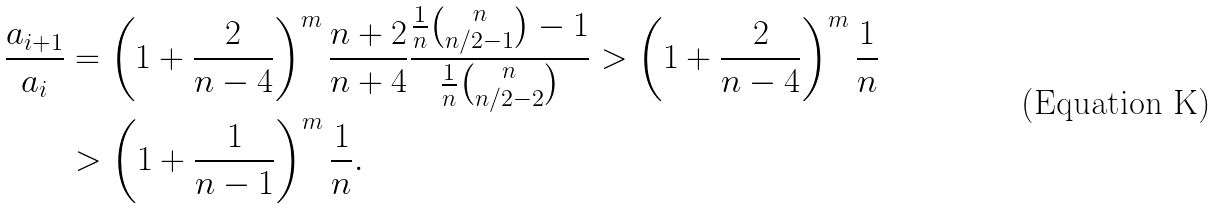<formula> <loc_0><loc_0><loc_500><loc_500>\frac { a _ { i + 1 } } { a _ { i } } & = \left ( 1 + \frac { 2 } { n - 4 } \right ) ^ { m } \frac { n + 2 } { n + 4 } \frac { \frac { 1 } { n } \binom { n } { n / 2 - 1 } - 1 } { \frac { 1 } { n } \binom { n } { n / 2 - 2 } } > \left ( 1 + \frac { 2 } { n - 4 } \right ) ^ { m } \frac { 1 } { n } \\ & > \left ( 1 + \frac { 1 } { n - 1 } \right ) ^ { m } \frac { 1 } { n } .</formula> 